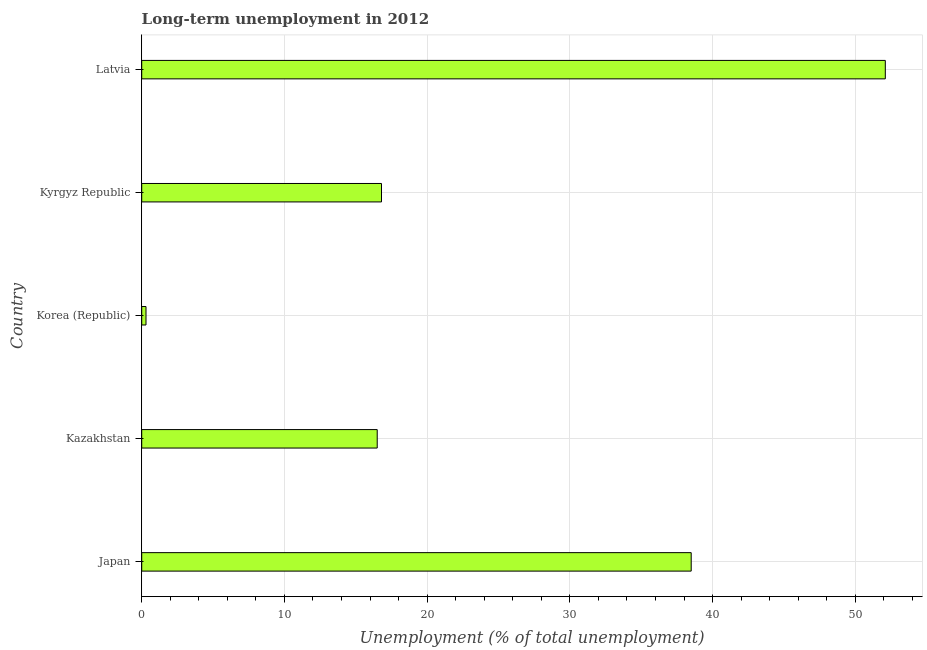Does the graph contain grids?
Your answer should be very brief. Yes. What is the title of the graph?
Provide a short and direct response. Long-term unemployment in 2012. What is the label or title of the X-axis?
Offer a terse response. Unemployment (% of total unemployment). What is the long-term unemployment in Japan?
Your answer should be compact. 38.5. Across all countries, what is the maximum long-term unemployment?
Keep it short and to the point. 52.1. Across all countries, what is the minimum long-term unemployment?
Your answer should be very brief. 0.3. In which country was the long-term unemployment maximum?
Your answer should be compact. Latvia. What is the sum of the long-term unemployment?
Offer a terse response. 124.2. What is the difference between the long-term unemployment in Japan and Korea (Republic)?
Offer a terse response. 38.2. What is the average long-term unemployment per country?
Your answer should be very brief. 24.84. What is the median long-term unemployment?
Your answer should be very brief. 16.8. In how many countries, is the long-term unemployment greater than 44 %?
Your answer should be very brief. 1. What is the ratio of the long-term unemployment in Japan to that in Kyrgyz Republic?
Make the answer very short. 2.29. What is the difference between the highest and the second highest long-term unemployment?
Your response must be concise. 13.6. What is the difference between the highest and the lowest long-term unemployment?
Provide a succinct answer. 51.8. How many bars are there?
Give a very brief answer. 5. How many countries are there in the graph?
Give a very brief answer. 5. What is the difference between two consecutive major ticks on the X-axis?
Your answer should be very brief. 10. Are the values on the major ticks of X-axis written in scientific E-notation?
Ensure brevity in your answer.  No. What is the Unemployment (% of total unemployment) in Japan?
Give a very brief answer. 38.5. What is the Unemployment (% of total unemployment) of Korea (Republic)?
Your response must be concise. 0.3. What is the Unemployment (% of total unemployment) of Kyrgyz Republic?
Keep it short and to the point. 16.8. What is the Unemployment (% of total unemployment) of Latvia?
Keep it short and to the point. 52.1. What is the difference between the Unemployment (% of total unemployment) in Japan and Kazakhstan?
Make the answer very short. 22. What is the difference between the Unemployment (% of total unemployment) in Japan and Korea (Republic)?
Offer a terse response. 38.2. What is the difference between the Unemployment (% of total unemployment) in Japan and Kyrgyz Republic?
Provide a succinct answer. 21.7. What is the difference between the Unemployment (% of total unemployment) in Japan and Latvia?
Your answer should be compact. -13.6. What is the difference between the Unemployment (% of total unemployment) in Kazakhstan and Korea (Republic)?
Ensure brevity in your answer.  16.2. What is the difference between the Unemployment (% of total unemployment) in Kazakhstan and Latvia?
Keep it short and to the point. -35.6. What is the difference between the Unemployment (% of total unemployment) in Korea (Republic) and Kyrgyz Republic?
Your answer should be compact. -16.5. What is the difference between the Unemployment (% of total unemployment) in Korea (Republic) and Latvia?
Ensure brevity in your answer.  -51.8. What is the difference between the Unemployment (% of total unemployment) in Kyrgyz Republic and Latvia?
Ensure brevity in your answer.  -35.3. What is the ratio of the Unemployment (% of total unemployment) in Japan to that in Kazakhstan?
Keep it short and to the point. 2.33. What is the ratio of the Unemployment (% of total unemployment) in Japan to that in Korea (Republic)?
Your answer should be very brief. 128.33. What is the ratio of the Unemployment (% of total unemployment) in Japan to that in Kyrgyz Republic?
Give a very brief answer. 2.29. What is the ratio of the Unemployment (% of total unemployment) in Japan to that in Latvia?
Your answer should be compact. 0.74. What is the ratio of the Unemployment (% of total unemployment) in Kazakhstan to that in Korea (Republic)?
Give a very brief answer. 55. What is the ratio of the Unemployment (% of total unemployment) in Kazakhstan to that in Kyrgyz Republic?
Keep it short and to the point. 0.98. What is the ratio of the Unemployment (% of total unemployment) in Kazakhstan to that in Latvia?
Provide a succinct answer. 0.32. What is the ratio of the Unemployment (% of total unemployment) in Korea (Republic) to that in Kyrgyz Republic?
Offer a very short reply. 0.02. What is the ratio of the Unemployment (% of total unemployment) in Korea (Republic) to that in Latvia?
Make the answer very short. 0.01. What is the ratio of the Unemployment (% of total unemployment) in Kyrgyz Republic to that in Latvia?
Provide a short and direct response. 0.32. 